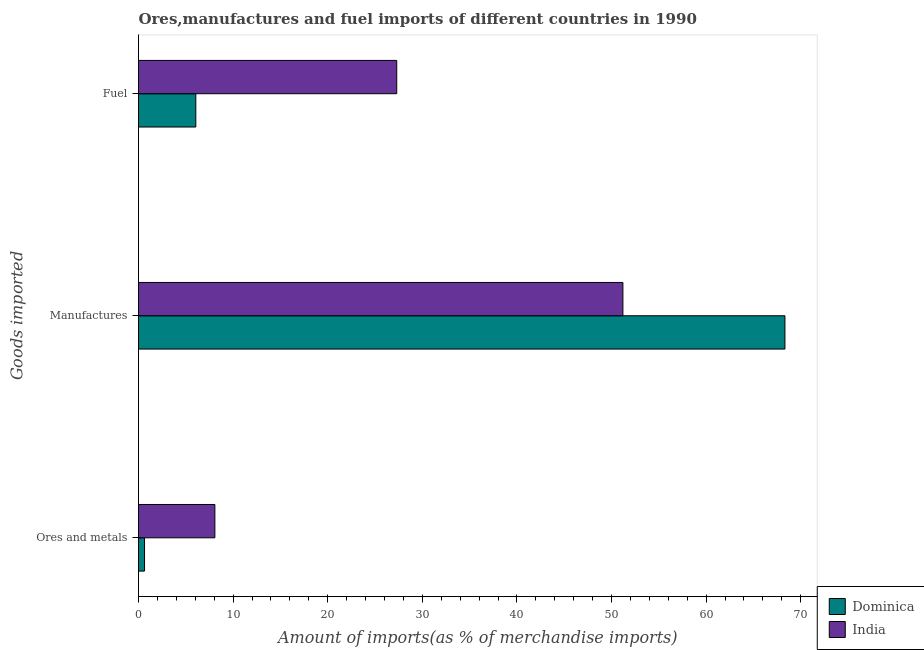Are the number of bars on each tick of the Y-axis equal?
Ensure brevity in your answer.  Yes. How many bars are there on the 1st tick from the top?
Make the answer very short. 2. How many bars are there on the 1st tick from the bottom?
Give a very brief answer. 2. What is the label of the 3rd group of bars from the top?
Your answer should be compact. Ores and metals. What is the percentage of ores and metals imports in India?
Offer a terse response. 8.07. Across all countries, what is the maximum percentage of manufactures imports?
Your answer should be very brief. 68.33. Across all countries, what is the minimum percentage of manufactures imports?
Your response must be concise. 51.2. What is the total percentage of manufactures imports in the graph?
Your answer should be very brief. 119.54. What is the difference between the percentage of ores and metals imports in Dominica and that in India?
Your answer should be compact. -7.44. What is the difference between the percentage of fuel imports in Dominica and the percentage of manufactures imports in India?
Make the answer very short. -45.15. What is the average percentage of ores and metals imports per country?
Your answer should be very brief. 4.35. What is the difference between the percentage of ores and metals imports and percentage of manufactures imports in Dominica?
Provide a short and direct response. -67.69. In how many countries, is the percentage of fuel imports greater than 40 %?
Offer a terse response. 0. What is the ratio of the percentage of ores and metals imports in Dominica to that in India?
Provide a succinct answer. 0.08. What is the difference between the highest and the second highest percentage of manufactures imports?
Give a very brief answer. 17.13. What is the difference between the highest and the lowest percentage of fuel imports?
Your response must be concise. 21.24. In how many countries, is the percentage of manufactures imports greater than the average percentage of manufactures imports taken over all countries?
Ensure brevity in your answer.  1. What does the 2nd bar from the top in Fuel represents?
Offer a very short reply. Dominica. What does the 1st bar from the bottom in Ores and metals represents?
Keep it short and to the point. Dominica. How many countries are there in the graph?
Offer a very short reply. 2. What is the difference between two consecutive major ticks on the X-axis?
Offer a terse response. 10. Are the values on the major ticks of X-axis written in scientific E-notation?
Keep it short and to the point. No. Does the graph contain any zero values?
Provide a succinct answer. No. Does the graph contain grids?
Offer a very short reply. No. How many legend labels are there?
Ensure brevity in your answer.  2. How are the legend labels stacked?
Offer a very short reply. Vertical. What is the title of the graph?
Give a very brief answer. Ores,manufactures and fuel imports of different countries in 1990. What is the label or title of the X-axis?
Your answer should be compact. Amount of imports(as % of merchandise imports). What is the label or title of the Y-axis?
Your answer should be very brief. Goods imported. What is the Amount of imports(as % of merchandise imports) of Dominica in Ores and metals?
Your answer should be compact. 0.64. What is the Amount of imports(as % of merchandise imports) of India in Ores and metals?
Provide a succinct answer. 8.07. What is the Amount of imports(as % of merchandise imports) in Dominica in Manufactures?
Ensure brevity in your answer.  68.33. What is the Amount of imports(as % of merchandise imports) of India in Manufactures?
Give a very brief answer. 51.2. What is the Amount of imports(as % of merchandise imports) of Dominica in Fuel?
Offer a very short reply. 6.06. What is the Amount of imports(as % of merchandise imports) in India in Fuel?
Your response must be concise. 27.3. Across all Goods imported, what is the maximum Amount of imports(as % of merchandise imports) of Dominica?
Keep it short and to the point. 68.33. Across all Goods imported, what is the maximum Amount of imports(as % of merchandise imports) in India?
Offer a very short reply. 51.2. Across all Goods imported, what is the minimum Amount of imports(as % of merchandise imports) of Dominica?
Your answer should be compact. 0.64. Across all Goods imported, what is the minimum Amount of imports(as % of merchandise imports) in India?
Your answer should be compact. 8.07. What is the total Amount of imports(as % of merchandise imports) of Dominica in the graph?
Provide a short and direct response. 75.03. What is the total Amount of imports(as % of merchandise imports) of India in the graph?
Your response must be concise. 86.57. What is the difference between the Amount of imports(as % of merchandise imports) in Dominica in Ores and metals and that in Manufactures?
Offer a terse response. -67.69. What is the difference between the Amount of imports(as % of merchandise imports) of India in Ores and metals and that in Manufactures?
Offer a very short reply. -43.13. What is the difference between the Amount of imports(as % of merchandise imports) of Dominica in Ores and metals and that in Fuel?
Your answer should be compact. -5.42. What is the difference between the Amount of imports(as % of merchandise imports) of India in Ores and metals and that in Fuel?
Ensure brevity in your answer.  -19.22. What is the difference between the Amount of imports(as % of merchandise imports) in Dominica in Manufactures and that in Fuel?
Your answer should be compact. 62.27. What is the difference between the Amount of imports(as % of merchandise imports) in India in Manufactures and that in Fuel?
Make the answer very short. 23.91. What is the difference between the Amount of imports(as % of merchandise imports) in Dominica in Ores and metals and the Amount of imports(as % of merchandise imports) in India in Manufactures?
Your answer should be very brief. -50.57. What is the difference between the Amount of imports(as % of merchandise imports) in Dominica in Ores and metals and the Amount of imports(as % of merchandise imports) in India in Fuel?
Make the answer very short. -26.66. What is the difference between the Amount of imports(as % of merchandise imports) in Dominica in Manufactures and the Amount of imports(as % of merchandise imports) in India in Fuel?
Give a very brief answer. 41.04. What is the average Amount of imports(as % of merchandise imports) of Dominica per Goods imported?
Your answer should be compact. 25.01. What is the average Amount of imports(as % of merchandise imports) of India per Goods imported?
Make the answer very short. 28.86. What is the difference between the Amount of imports(as % of merchandise imports) of Dominica and Amount of imports(as % of merchandise imports) of India in Ores and metals?
Provide a succinct answer. -7.44. What is the difference between the Amount of imports(as % of merchandise imports) of Dominica and Amount of imports(as % of merchandise imports) of India in Manufactures?
Offer a very short reply. 17.13. What is the difference between the Amount of imports(as % of merchandise imports) in Dominica and Amount of imports(as % of merchandise imports) in India in Fuel?
Your response must be concise. -21.24. What is the ratio of the Amount of imports(as % of merchandise imports) of Dominica in Ores and metals to that in Manufactures?
Provide a succinct answer. 0.01. What is the ratio of the Amount of imports(as % of merchandise imports) of India in Ores and metals to that in Manufactures?
Your answer should be compact. 0.16. What is the ratio of the Amount of imports(as % of merchandise imports) in Dominica in Ores and metals to that in Fuel?
Make the answer very short. 0.11. What is the ratio of the Amount of imports(as % of merchandise imports) of India in Ores and metals to that in Fuel?
Your answer should be compact. 0.3. What is the ratio of the Amount of imports(as % of merchandise imports) of Dominica in Manufactures to that in Fuel?
Ensure brevity in your answer.  11.28. What is the ratio of the Amount of imports(as % of merchandise imports) of India in Manufactures to that in Fuel?
Provide a short and direct response. 1.88. What is the difference between the highest and the second highest Amount of imports(as % of merchandise imports) of Dominica?
Provide a short and direct response. 62.27. What is the difference between the highest and the second highest Amount of imports(as % of merchandise imports) in India?
Your answer should be very brief. 23.91. What is the difference between the highest and the lowest Amount of imports(as % of merchandise imports) of Dominica?
Provide a succinct answer. 67.69. What is the difference between the highest and the lowest Amount of imports(as % of merchandise imports) in India?
Keep it short and to the point. 43.13. 